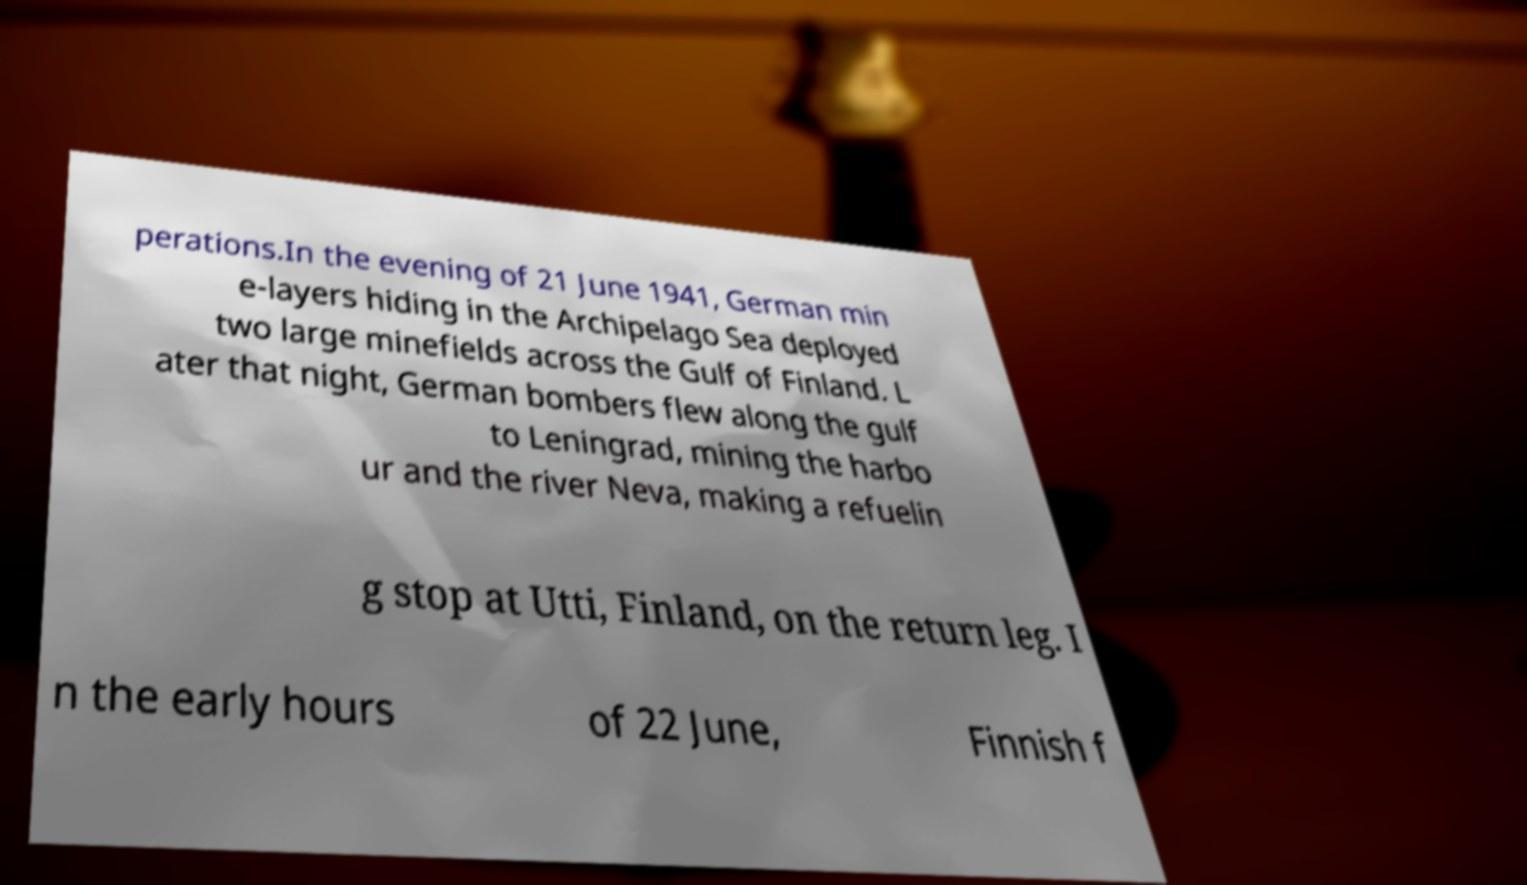For documentation purposes, I need the text within this image transcribed. Could you provide that? perations.In the evening of 21 June 1941, German min e-layers hiding in the Archipelago Sea deployed two large minefields across the Gulf of Finland. L ater that night, German bombers flew along the gulf to Leningrad, mining the harbo ur and the river Neva, making a refuelin g stop at Utti, Finland, on the return leg. I n the early hours of 22 June, Finnish f 